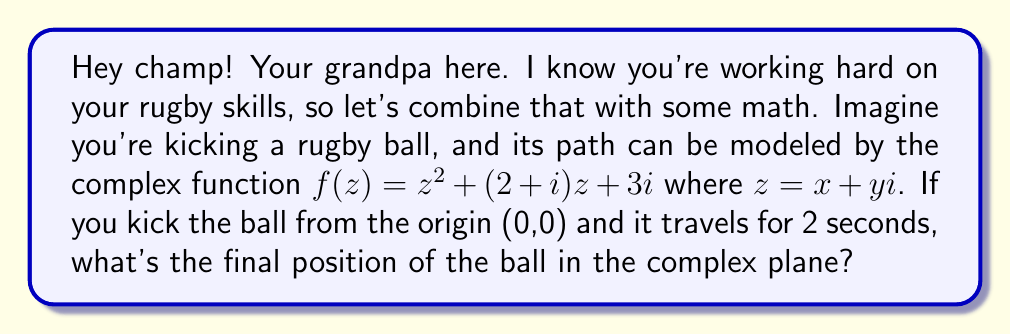Provide a solution to this math problem. Alright, let's break this down step-by-step:

1) The function $f(z) = z^2 + (2+i)z + 3i$ represents the path of the ball in the complex plane.

2) We need to find $f(2)$ since the ball travels for 2 seconds. This means we substitute $z = 2$ into our function.

3) Let's calculate each term:
   
   a) $z^2 = 2^2 = 4$
   
   b) $(2+i)z = (2+i)(2) = 4 + 2i$
   
   c) $3i$ remains as is

4) Now, let's add these terms:

   $f(2) = 4 + (4 + 2i) + 3i$
   
   $f(2) = 4 + 4 + 2i + 3i$
   
   $f(2) = 8 + 5i$

5) The final position is represented by the complex number $8 + 5i$.

6) In the complex plane, this means the ball is at the point (8, 5).

[asy]
import graph;
size(200);
real xmax = 10;
real ymax = 6;
xaxis("Re(z)", -1, xmax, arrow=Arrow);
yaxis("Im(z)", -1, ymax, arrow=Arrow);
dot((8,5), red);
label("(8, 5)", (8,5), NE);
[/asy]
Answer: The final position of the rugby ball in the complex plane is $8 + 5i$, or the point (8, 5). 